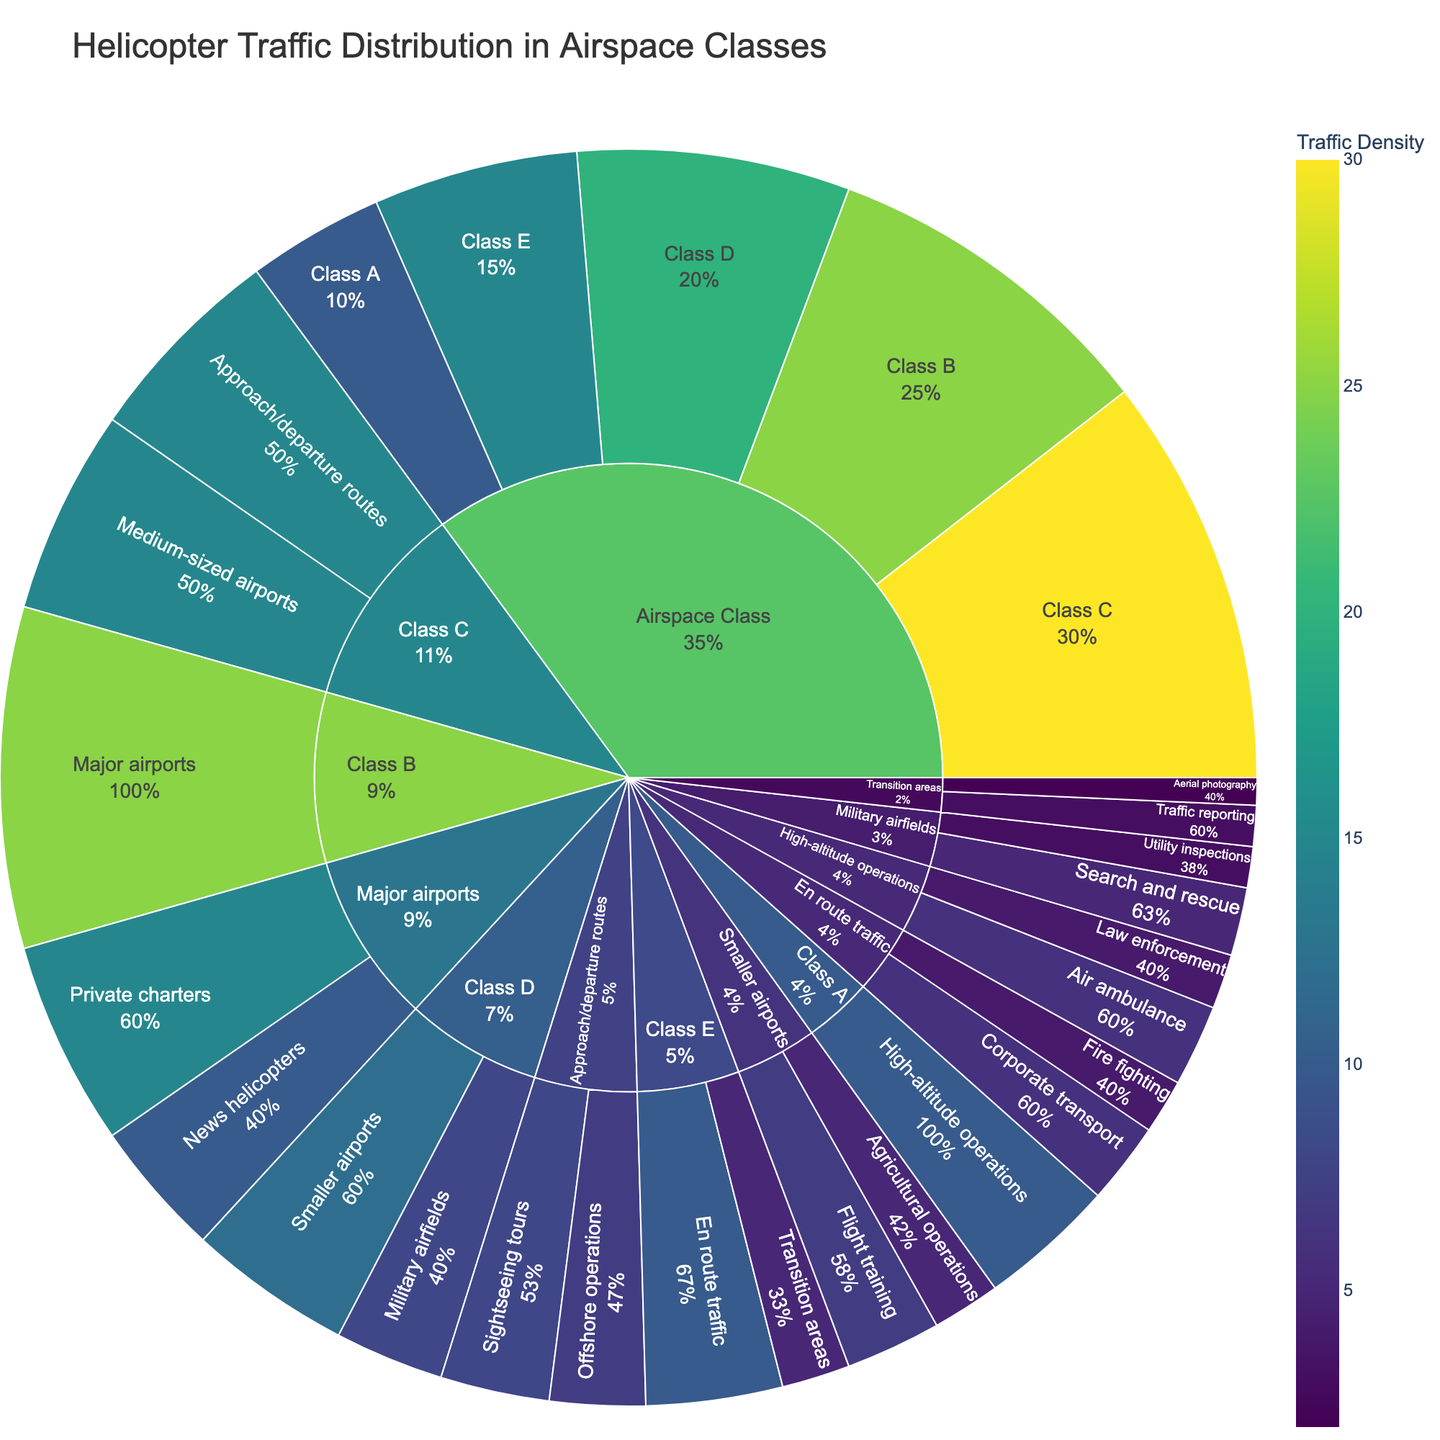What is the title of the figure? Look at the top of the figure where the title is usually located.
Answer: Helicopter Traffic Distribution in Airspace Classes Which airspace class has the highest helicopter traffic? Check the segment with the largest value in the outer circle of the sunburst plot.
Answer: Class C How much helicopter traffic is handled by Class E? Find the segment labeled Class E and note the value associated with it.
Answer: 15 What type of operations has the most helicopter traffic within Class D? Within the Class D segment, compare the values of the subcategories to identify the highest one.
Answer: Smaller airports How does traffic for Air ambulance operations compare to Law enforcement within Class A? Find the subcategories of High-altitude operations within Class A and compare their values.
Answer: Air ambulance (6) has higher traffic than Law enforcement (4) What percentage of helicopter traffic is associated with Private charters at Major airports? Locate the Private charters segment under Major airports and note the percentage indicated by the sunburst plot.
Answer: 60% What is the combined helicopter traffic for Military airfields and Utility inspections within Class D? Sum the values for Military airfields and Utility inspections under Class D.
Answer: 8 Which category under Approach/departure routes has more helicopter traffic, Sightseeing tours, or Offshore operations? Compare the values of Sightseeing tours and Offshore operations under the Approach/departure routes segment.
Answer: Sightseeing tours What is the proportion of Search and rescue operations within Military airfields? Consider the Search and rescue segment under Military airfields and relate its value to the total for Military airfields (segment percentage indicated in the plot).
Answer: 62.5% How much more helicopter traffic is there in Medium-sized airports compared to Transition areas? Subtract the value of Transition areas from the value of Medium-sized airports to find the difference.
Answer: 10 